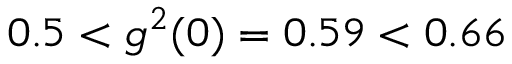Convert formula to latex. <formula><loc_0><loc_0><loc_500><loc_500>0 . 5 < g ^ { 2 } ( 0 ) = 0 . 5 9 < 0 . 6 6</formula> 